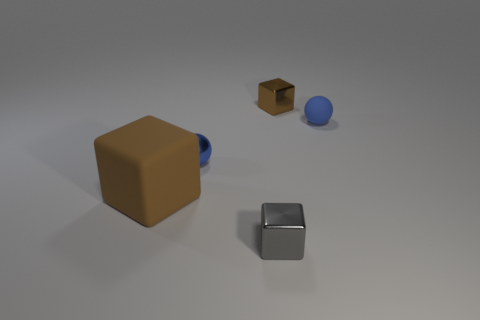Add 4 brown rubber blocks. How many objects exist? 9 Subtract all tiny metal cubes. How many cubes are left? 1 Subtract all brown blocks. How many blocks are left? 1 Subtract all cubes. How many objects are left? 2 Subtract all blue cylinders. How many brown blocks are left? 2 Subtract all small blue metal spheres. Subtract all big brown rubber blocks. How many objects are left? 3 Add 5 big matte things. How many big matte things are left? 6 Add 1 tiny blue matte things. How many tiny blue matte things exist? 2 Subtract 0 green spheres. How many objects are left? 5 Subtract all red spheres. Subtract all gray cylinders. How many spheres are left? 2 